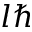<formula> <loc_0><loc_0><loc_500><loc_500>l \hbar</formula> 